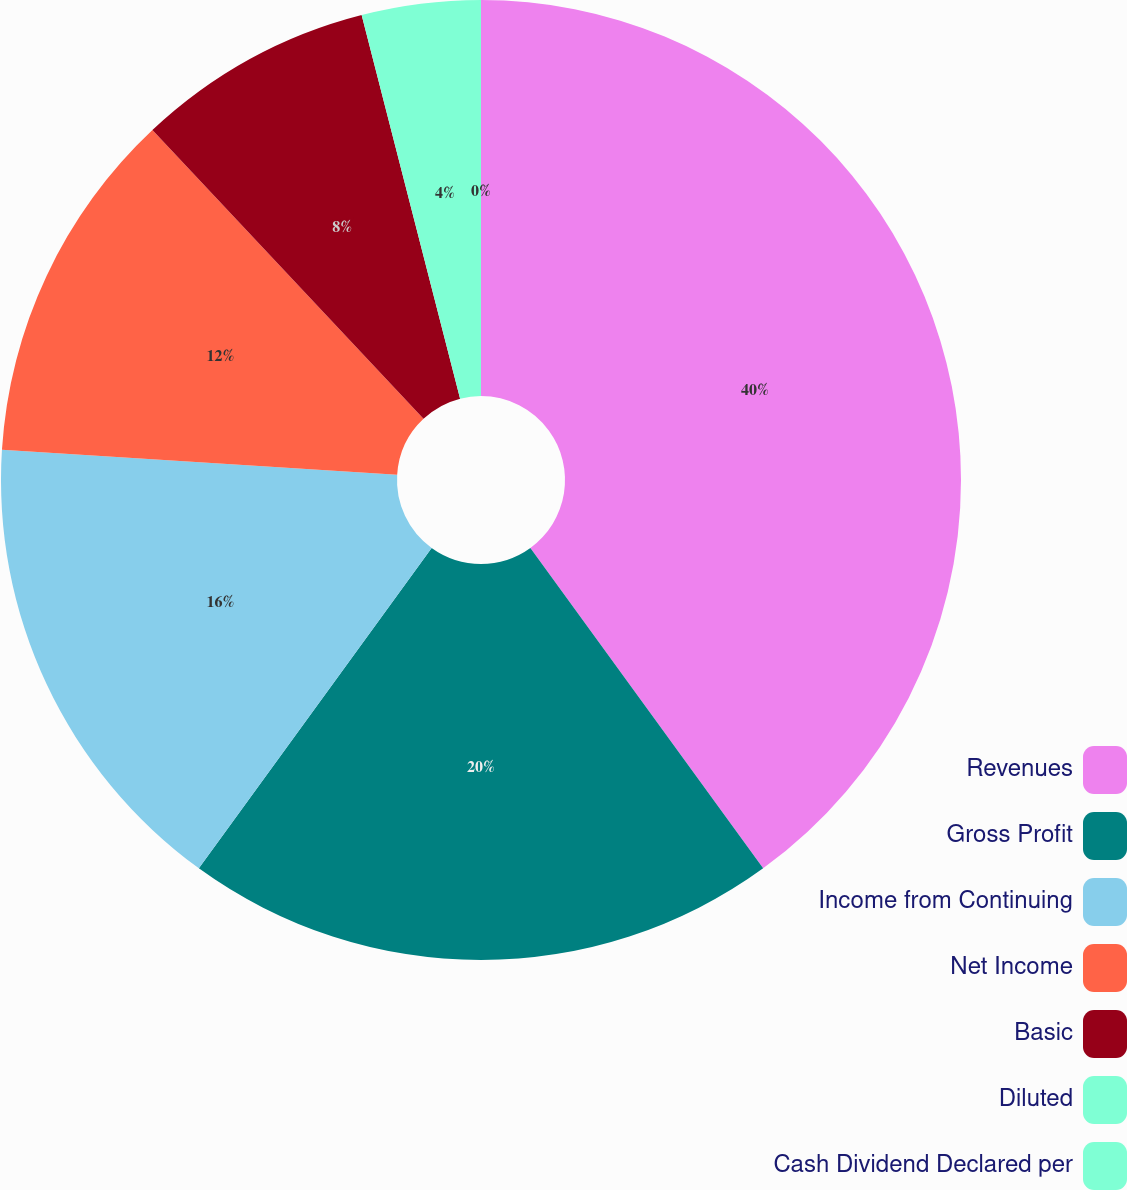Convert chart. <chart><loc_0><loc_0><loc_500><loc_500><pie_chart><fcel>Revenues<fcel>Gross Profit<fcel>Income from Continuing<fcel>Net Income<fcel>Basic<fcel>Diluted<fcel>Cash Dividend Declared per<nl><fcel>40.0%<fcel>20.0%<fcel>16.0%<fcel>12.0%<fcel>8.0%<fcel>4.0%<fcel>0.0%<nl></chart> 